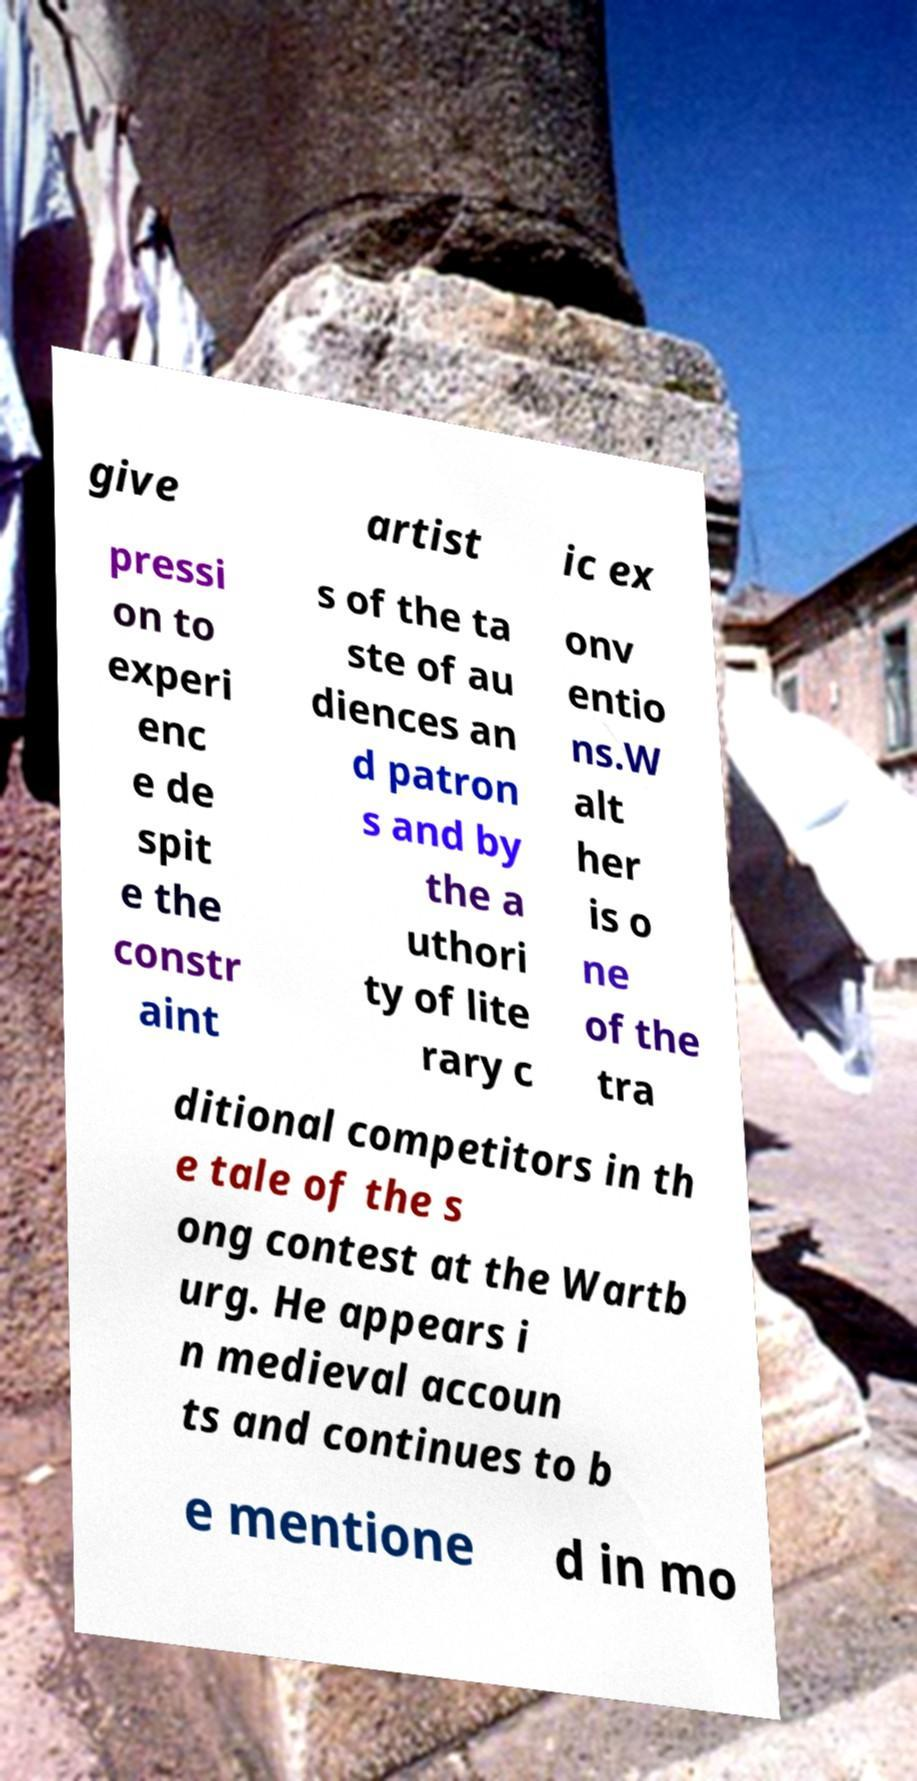I need the written content from this picture converted into text. Can you do that? give artist ic ex pressi on to experi enc e de spit e the constr aint s of the ta ste of au diences an d patron s and by the a uthori ty of lite rary c onv entio ns.W alt her is o ne of the tra ditional competitors in th e tale of the s ong contest at the Wartb urg. He appears i n medieval accoun ts and continues to b e mentione d in mo 